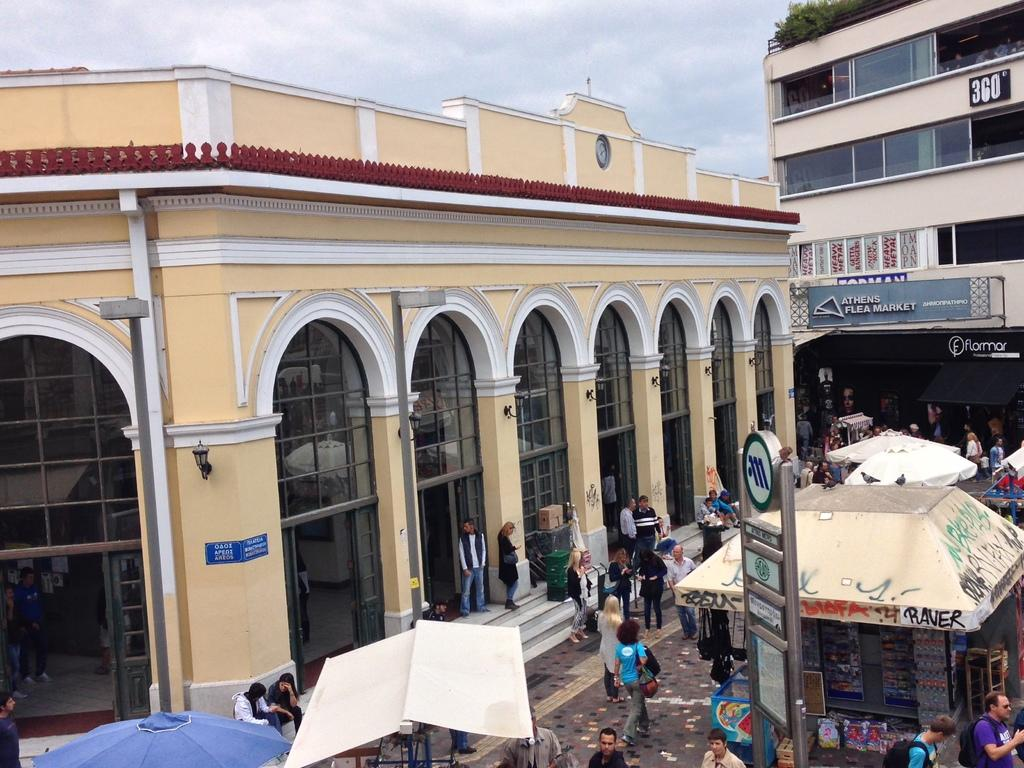What are the people in the image doing? The people in the image are walking on a pavement. Are there any people sitting in the image? Yes, some people are sitting near a building. What can be seen in the middle of the image? There are stalls in the middle of the image. What is visible in the background of the image? There are buildings and the sky in the background. What type of floor can be seen in the image? The image does not show the floor; it focuses on people walking on a pavement and other elements. Is there a spring season depicted in the image? The image does not depict a specific season; it only shows people, stalls, buildings, and the sky. 